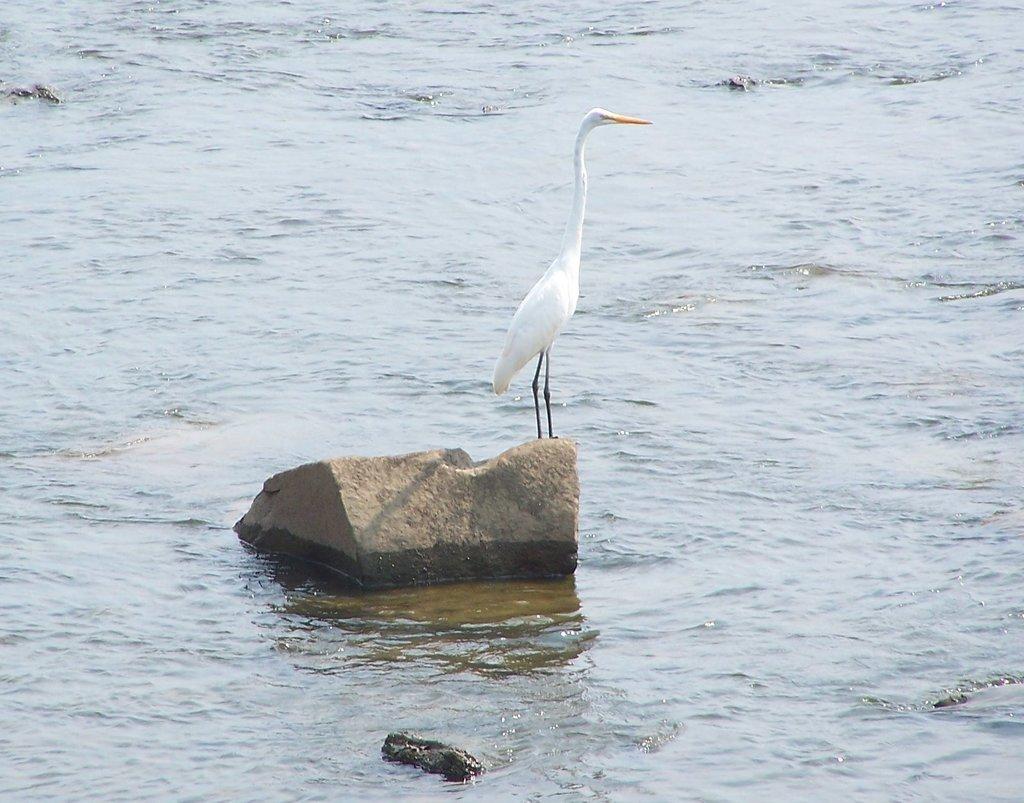How would you summarize this image in a sentence or two? In this image we can see a water body. We can also see a crane on the rock. 